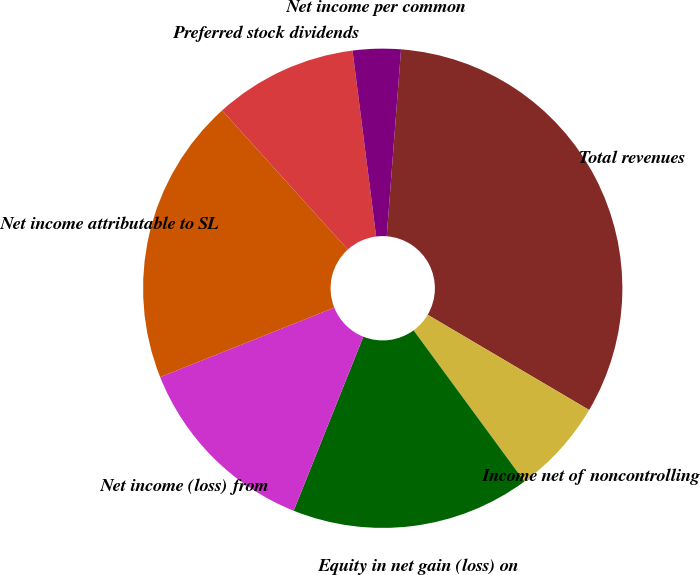Convert chart. <chart><loc_0><loc_0><loc_500><loc_500><pie_chart><fcel>Total revenues<fcel>Income net of noncontrolling<fcel>Equity in net gain (loss) on<fcel>Net income (loss) from<fcel>Net income attributable to SL<fcel>Preferred stock dividends<fcel>Net income per common<nl><fcel>32.26%<fcel>6.45%<fcel>16.13%<fcel>12.9%<fcel>19.35%<fcel>9.68%<fcel>3.23%<nl></chart> 